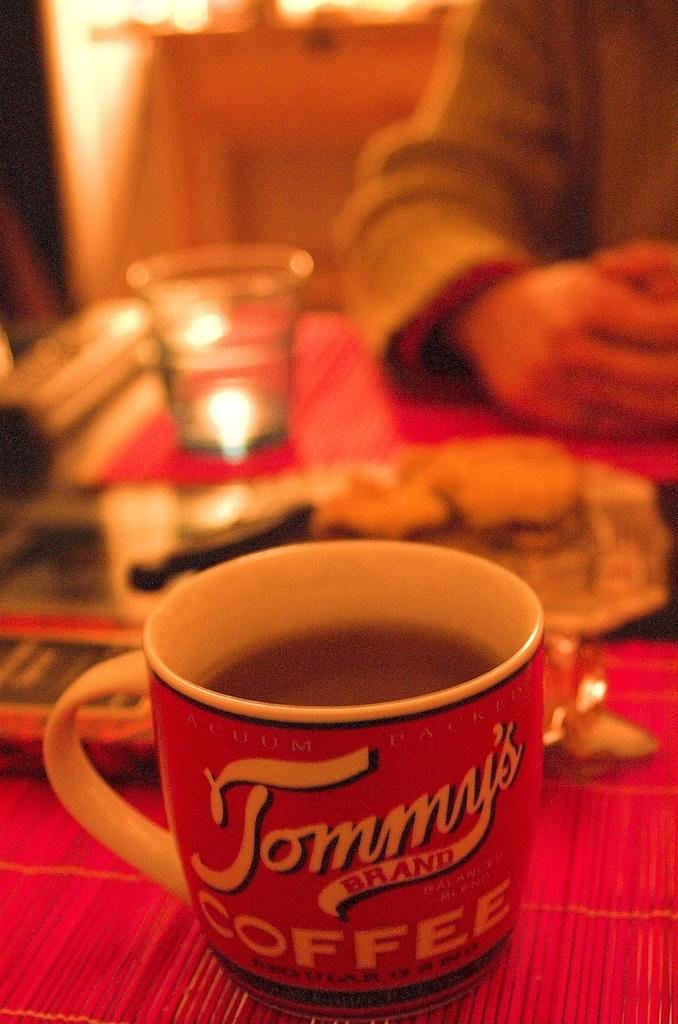What is contained in the cup that is visible in the image? There is a cup with liquid in the image. What other container is present in the image? There is a glass in the image. What can be seen on a raised surface in the image? There are objects on a platform in the image. Whose hand is visible in the image? The hand of a person is visible in the image. How would you describe the background of the image? The background of the image is blurred. What type of writing can be seen on the roof in the image? There is no roof or writing present in the image. What is the person holding in the image? The person's hand is visible, but there is no sack or any other object being held. 